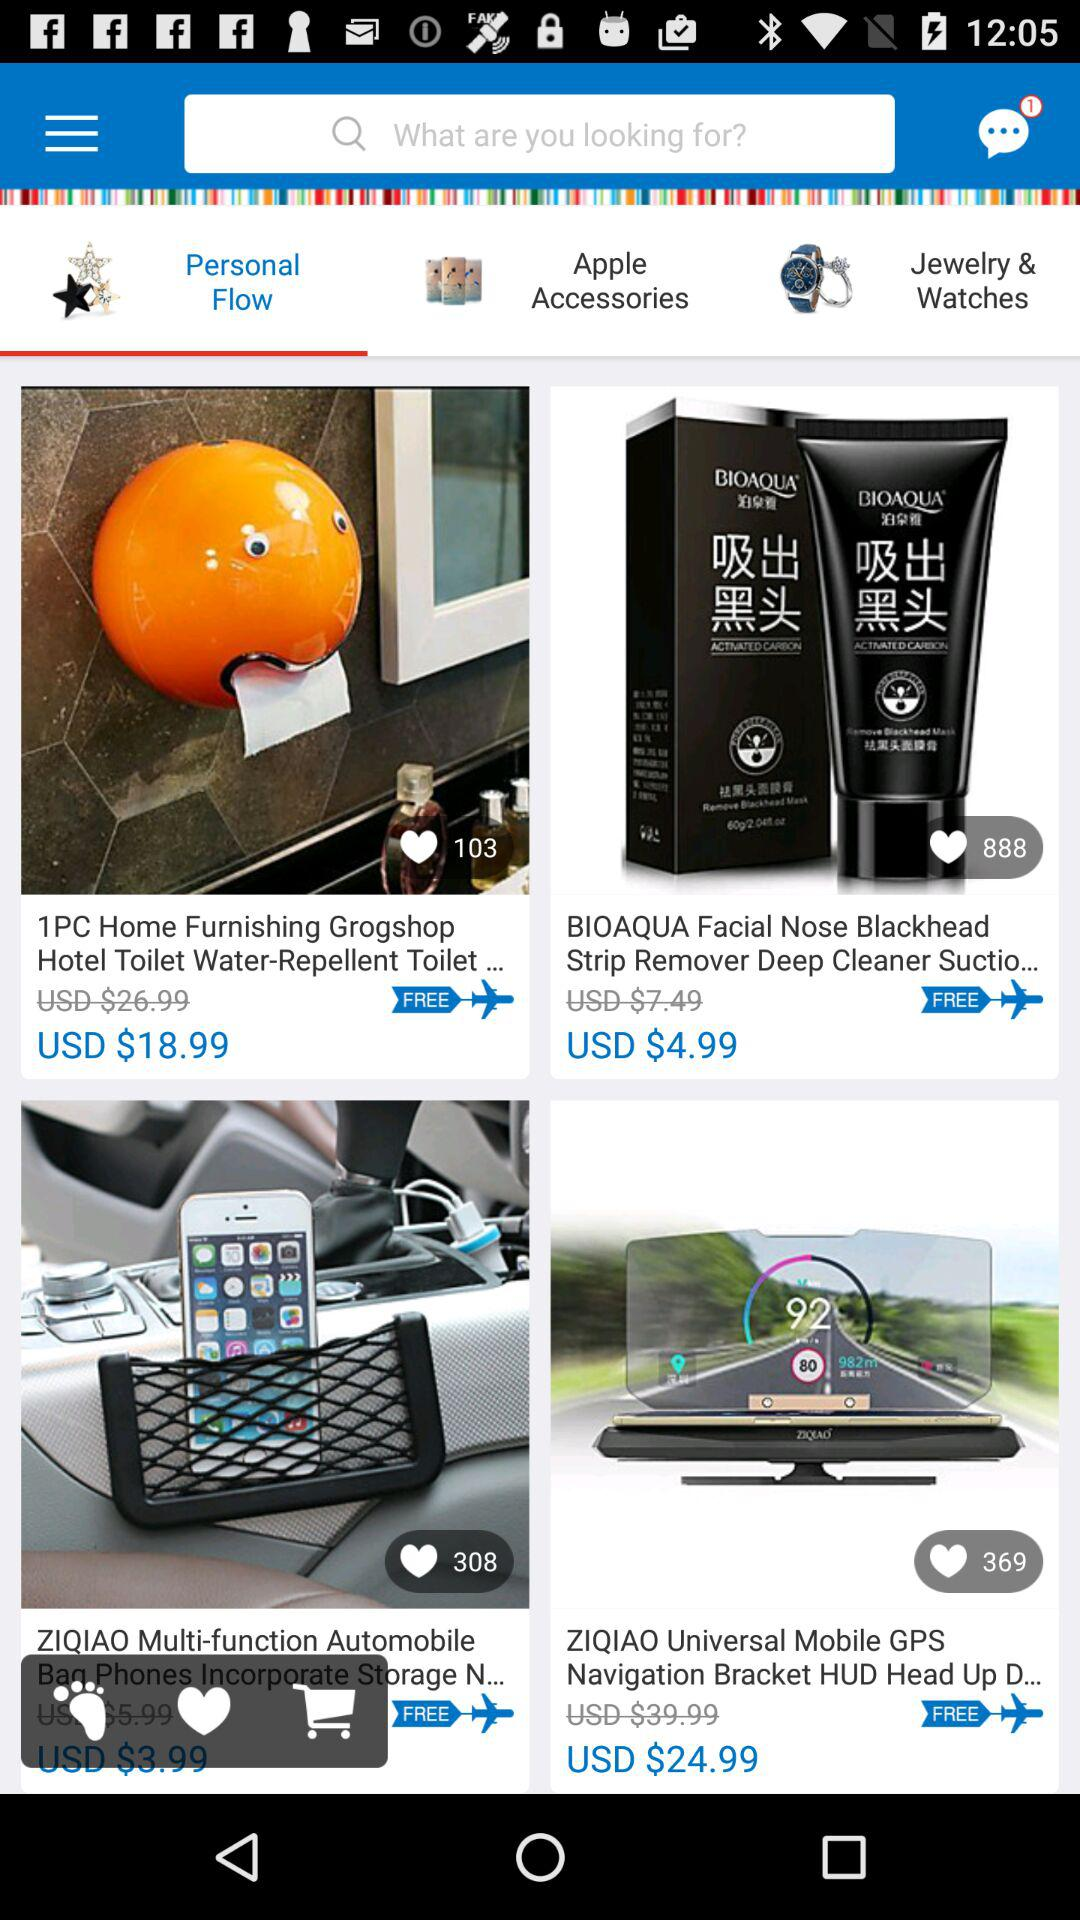How many people like the "ZIQIAO Universal Mobile GPS Navigation Bracket HUD Head Up D..."? The people who liked the "ZIQIAO Universal Mobile GPS Navigation Bracket HUD Head Up D..." are 369. 